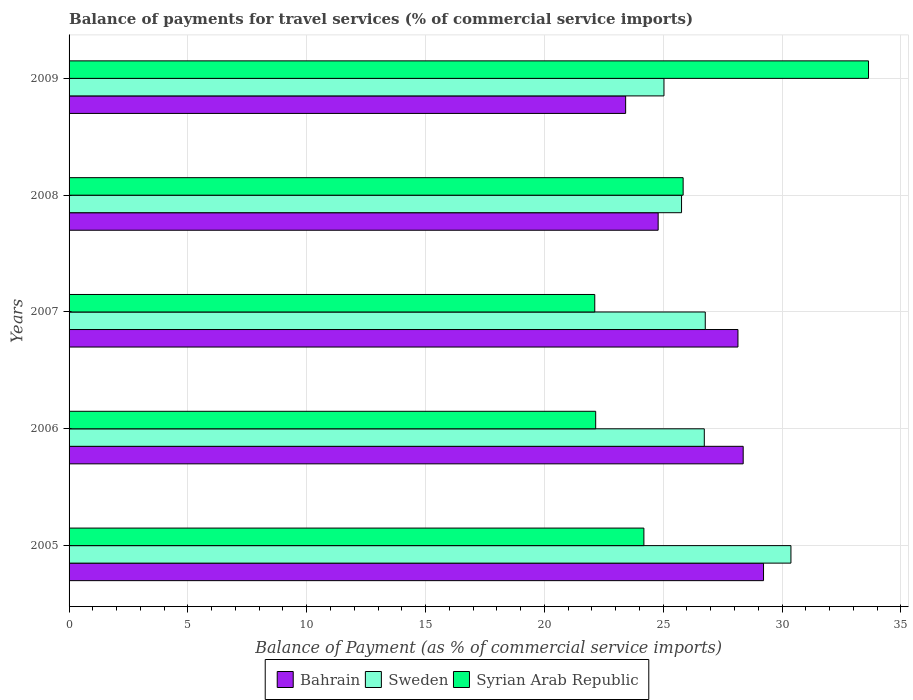How many groups of bars are there?
Ensure brevity in your answer.  5. Are the number of bars on each tick of the Y-axis equal?
Give a very brief answer. Yes. How many bars are there on the 4th tick from the bottom?
Your response must be concise. 3. What is the label of the 1st group of bars from the top?
Your response must be concise. 2009. In how many cases, is the number of bars for a given year not equal to the number of legend labels?
Your answer should be compact. 0. What is the balance of payments for travel services in Syrian Arab Republic in 2007?
Your response must be concise. 22.12. Across all years, what is the maximum balance of payments for travel services in Sweden?
Provide a succinct answer. 30.37. Across all years, what is the minimum balance of payments for travel services in Bahrain?
Keep it short and to the point. 23.42. In which year was the balance of payments for travel services in Bahrain maximum?
Offer a terse response. 2005. In which year was the balance of payments for travel services in Syrian Arab Republic minimum?
Your response must be concise. 2007. What is the total balance of payments for travel services in Bahrain in the graph?
Ensure brevity in your answer.  133.94. What is the difference between the balance of payments for travel services in Syrian Arab Republic in 2005 and that in 2006?
Your response must be concise. 2.03. What is the difference between the balance of payments for travel services in Syrian Arab Republic in 2006 and the balance of payments for travel services in Sweden in 2008?
Provide a succinct answer. -3.61. What is the average balance of payments for travel services in Syrian Arab Republic per year?
Your answer should be very brief. 25.59. In the year 2006, what is the difference between the balance of payments for travel services in Bahrain and balance of payments for travel services in Sweden?
Your response must be concise. 1.64. In how many years, is the balance of payments for travel services in Sweden greater than 15 %?
Keep it short and to the point. 5. What is the ratio of the balance of payments for travel services in Sweden in 2006 to that in 2009?
Your response must be concise. 1.07. Is the difference between the balance of payments for travel services in Bahrain in 2005 and 2008 greater than the difference between the balance of payments for travel services in Sweden in 2005 and 2008?
Your answer should be compact. No. What is the difference between the highest and the second highest balance of payments for travel services in Sweden?
Make the answer very short. 3.6. What is the difference between the highest and the lowest balance of payments for travel services in Sweden?
Provide a short and direct response. 5.34. In how many years, is the balance of payments for travel services in Syrian Arab Republic greater than the average balance of payments for travel services in Syrian Arab Republic taken over all years?
Offer a very short reply. 2. What does the 1st bar from the top in 2007 represents?
Your answer should be very brief. Syrian Arab Republic. What does the 3rd bar from the bottom in 2008 represents?
Give a very brief answer. Syrian Arab Republic. Is it the case that in every year, the sum of the balance of payments for travel services in Sweden and balance of payments for travel services in Bahrain is greater than the balance of payments for travel services in Syrian Arab Republic?
Offer a very short reply. Yes. How many bars are there?
Ensure brevity in your answer.  15. Are all the bars in the graph horizontal?
Give a very brief answer. Yes. What is the difference between two consecutive major ticks on the X-axis?
Your answer should be compact. 5. Are the values on the major ticks of X-axis written in scientific E-notation?
Your answer should be very brief. No. What is the title of the graph?
Offer a very short reply. Balance of payments for travel services (% of commercial service imports). Does "Chad" appear as one of the legend labels in the graph?
Offer a very short reply. No. What is the label or title of the X-axis?
Offer a terse response. Balance of Payment (as % of commercial service imports). What is the Balance of Payment (as % of commercial service imports) in Bahrain in 2005?
Your answer should be very brief. 29.22. What is the Balance of Payment (as % of commercial service imports) of Sweden in 2005?
Provide a short and direct response. 30.37. What is the Balance of Payment (as % of commercial service imports) in Syrian Arab Republic in 2005?
Your answer should be very brief. 24.19. What is the Balance of Payment (as % of commercial service imports) of Bahrain in 2006?
Provide a short and direct response. 28.36. What is the Balance of Payment (as % of commercial service imports) of Sweden in 2006?
Provide a succinct answer. 26.73. What is the Balance of Payment (as % of commercial service imports) of Syrian Arab Republic in 2006?
Keep it short and to the point. 22.16. What is the Balance of Payment (as % of commercial service imports) in Bahrain in 2007?
Ensure brevity in your answer.  28.14. What is the Balance of Payment (as % of commercial service imports) of Sweden in 2007?
Offer a terse response. 26.77. What is the Balance of Payment (as % of commercial service imports) of Syrian Arab Republic in 2007?
Offer a very short reply. 22.12. What is the Balance of Payment (as % of commercial service imports) of Bahrain in 2008?
Offer a terse response. 24.79. What is the Balance of Payment (as % of commercial service imports) of Sweden in 2008?
Offer a very short reply. 25.77. What is the Balance of Payment (as % of commercial service imports) of Syrian Arab Republic in 2008?
Your answer should be very brief. 25.84. What is the Balance of Payment (as % of commercial service imports) in Bahrain in 2009?
Your response must be concise. 23.42. What is the Balance of Payment (as % of commercial service imports) of Sweden in 2009?
Your response must be concise. 25.03. What is the Balance of Payment (as % of commercial service imports) of Syrian Arab Republic in 2009?
Provide a short and direct response. 33.64. Across all years, what is the maximum Balance of Payment (as % of commercial service imports) in Bahrain?
Give a very brief answer. 29.22. Across all years, what is the maximum Balance of Payment (as % of commercial service imports) in Sweden?
Your answer should be compact. 30.37. Across all years, what is the maximum Balance of Payment (as % of commercial service imports) of Syrian Arab Republic?
Make the answer very short. 33.64. Across all years, what is the minimum Balance of Payment (as % of commercial service imports) of Bahrain?
Give a very brief answer. 23.42. Across all years, what is the minimum Balance of Payment (as % of commercial service imports) in Sweden?
Give a very brief answer. 25.03. Across all years, what is the minimum Balance of Payment (as % of commercial service imports) of Syrian Arab Republic?
Make the answer very short. 22.12. What is the total Balance of Payment (as % of commercial service imports) of Bahrain in the graph?
Provide a succinct answer. 133.94. What is the total Balance of Payment (as % of commercial service imports) in Sweden in the graph?
Your answer should be very brief. 134.67. What is the total Balance of Payment (as % of commercial service imports) of Syrian Arab Republic in the graph?
Make the answer very short. 127.94. What is the difference between the Balance of Payment (as % of commercial service imports) in Bahrain in 2005 and that in 2006?
Your answer should be compact. 0.86. What is the difference between the Balance of Payment (as % of commercial service imports) in Sweden in 2005 and that in 2006?
Offer a very short reply. 3.65. What is the difference between the Balance of Payment (as % of commercial service imports) of Syrian Arab Republic in 2005 and that in 2006?
Provide a succinct answer. 2.03. What is the difference between the Balance of Payment (as % of commercial service imports) in Bahrain in 2005 and that in 2007?
Your response must be concise. 1.08. What is the difference between the Balance of Payment (as % of commercial service imports) in Sweden in 2005 and that in 2007?
Offer a very short reply. 3.6. What is the difference between the Balance of Payment (as % of commercial service imports) in Syrian Arab Republic in 2005 and that in 2007?
Provide a short and direct response. 2.07. What is the difference between the Balance of Payment (as % of commercial service imports) in Bahrain in 2005 and that in 2008?
Keep it short and to the point. 4.43. What is the difference between the Balance of Payment (as % of commercial service imports) of Sweden in 2005 and that in 2008?
Your answer should be very brief. 4.6. What is the difference between the Balance of Payment (as % of commercial service imports) of Syrian Arab Republic in 2005 and that in 2008?
Your answer should be very brief. -1.65. What is the difference between the Balance of Payment (as % of commercial service imports) of Bahrain in 2005 and that in 2009?
Make the answer very short. 5.8. What is the difference between the Balance of Payment (as % of commercial service imports) in Sweden in 2005 and that in 2009?
Your answer should be very brief. 5.34. What is the difference between the Balance of Payment (as % of commercial service imports) of Syrian Arab Republic in 2005 and that in 2009?
Provide a short and direct response. -9.45. What is the difference between the Balance of Payment (as % of commercial service imports) in Bahrain in 2006 and that in 2007?
Your answer should be compact. 0.22. What is the difference between the Balance of Payment (as % of commercial service imports) in Sweden in 2006 and that in 2007?
Provide a short and direct response. -0.04. What is the difference between the Balance of Payment (as % of commercial service imports) of Syrian Arab Republic in 2006 and that in 2007?
Keep it short and to the point. 0.04. What is the difference between the Balance of Payment (as % of commercial service imports) in Bahrain in 2006 and that in 2008?
Give a very brief answer. 3.58. What is the difference between the Balance of Payment (as % of commercial service imports) of Sweden in 2006 and that in 2008?
Provide a short and direct response. 0.96. What is the difference between the Balance of Payment (as % of commercial service imports) in Syrian Arab Republic in 2006 and that in 2008?
Keep it short and to the point. -3.68. What is the difference between the Balance of Payment (as % of commercial service imports) in Bahrain in 2006 and that in 2009?
Offer a terse response. 4.95. What is the difference between the Balance of Payment (as % of commercial service imports) of Sweden in 2006 and that in 2009?
Keep it short and to the point. 1.7. What is the difference between the Balance of Payment (as % of commercial service imports) in Syrian Arab Republic in 2006 and that in 2009?
Make the answer very short. -11.48. What is the difference between the Balance of Payment (as % of commercial service imports) in Bahrain in 2007 and that in 2008?
Keep it short and to the point. 3.36. What is the difference between the Balance of Payment (as % of commercial service imports) in Sweden in 2007 and that in 2008?
Offer a very short reply. 1. What is the difference between the Balance of Payment (as % of commercial service imports) in Syrian Arab Republic in 2007 and that in 2008?
Your response must be concise. -3.72. What is the difference between the Balance of Payment (as % of commercial service imports) in Bahrain in 2007 and that in 2009?
Your answer should be very brief. 4.73. What is the difference between the Balance of Payment (as % of commercial service imports) of Sweden in 2007 and that in 2009?
Your answer should be very brief. 1.74. What is the difference between the Balance of Payment (as % of commercial service imports) in Syrian Arab Republic in 2007 and that in 2009?
Ensure brevity in your answer.  -11.52. What is the difference between the Balance of Payment (as % of commercial service imports) in Bahrain in 2008 and that in 2009?
Ensure brevity in your answer.  1.37. What is the difference between the Balance of Payment (as % of commercial service imports) in Sweden in 2008 and that in 2009?
Keep it short and to the point. 0.74. What is the difference between the Balance of Payment (as % of commercial service imports) in Syrian Arab Republic in 2008 and that in 2009?
Give a very brief answer. -7.8. What is the difference between the Balance of Payment (as % of commercial service imports) in Bahrain in 2005 and the Balance of Payment (as % of commercial service imports) in Sweden in 2006?
Your answer should be compact. 2.49. What is the difference between the Balance of Payment (as % of commercial service imports) in Bahrain in 2005 and the Balance of Payment (as % of commercial service imports) in Syrian Arab Republic in 2006?
Provide a short and direct response. 7.06. What is the difference between the Balance of Payment (as % of commercial service imports) in Sweden in 2005 and the Balance of Payment (as % of commercial service imports) in Syrian Arab Republic in 2006?
Offer a very short reply. 8.22. What is the difference between the Balance of Payment (as % of commercial service imports) of Bahrain in 2005 and the Balance of Payment (as % of commercial service imports) of Sweden in 2007?
Your answer should be very brief. 2.45. What is the difference between the Balance of Payment (as % of commercial service imports) of Bahrain in 2005 and the Balance of Payment (as % of commercial service imports) of Syrian Arab Republic in 2007?
Keep it short and to the point. 7.1. What is the difference between the Balance of Payment (as % of commercial service imports) in Sweden in 2005 and the Balance of Payment (as % of commercial service imports) in Syrian Arab Republic in 2007?
Offer a very short reply. 8.25. What is the difference between the Balance of Payment (as % of commercial service imports) of Bahrain in 2005 and the Balance of Payment (as % of commercial service imports) of Sweden in 2008?
Offer a very short reply. 3.45. What is the difference between the Balance of Payment (as % of commercial service imports) of Bahrain in 2005 and the Balance of Payment (as % of commercial service imports) of Syrian Arab Republic in 2008?
Provide a succinct answer. 3.38. What is the difference between the Balance of Payment (as % of commercial service imports) of Sweden in 2005 and the Balance of Payment (as % of commercial service imports) of Syrian Arab Republic in 2008?
Provide a succinct answer. 4.54. What is the difference between the Balance of Payment (as % of commercial service imports) in Bahrain in 2005 and the Balance of Payment (as % of commercial service imports) in Sweden in 2009?
Provide a succinct answer. 4.19. What is the difference between the Balance of Payment (as % of commercial service imports) of Bahrain in 2005 and the Balance of Payment (as % of commercial service imports) of Syrian Arab Republic in 2009?
Your response must be concise. -4.42. What is the difference between the Balance of Payment (as % of commercial service imports) in Sweden in 2005 and the Balance of Payment (as % of commercial service imports) in Syrian Arab Republic in 2009?
Keep it short and to the point. -3.26. What is the difference between the Balance of Payment (as % of commercial service imports) of Bahrain in 2006 and the Balance of Payment (as % of commercial service imports) of Sweden in 2007?
Offer a very short reply. 1.6. What is the difference between the Balance of Payment (as % of commercial service imports) of Bahrain in 2006 and the Balance of Payment (as % of commercial service imports) of Syrian Arab Republic in 2007?
Provide a succinct answer. 6.24. What is the difference between the Balance of Payment (as % of commercial service imports) in Sweden in 2006 and the Balance of Payment (as % of commercial service imports) in Syrian Arab Republic in 2007?
Keep it short and to the point. 4.61. What is the difference between the Balance of Payment (as % of commercial service imports) of Bahrain in 2006 and the Balance of Payment (as % of commercial service imports) of Sweden in 2008?
Provide a short and direct response. 2.59. What is the difference between the Balance of Payment (as % of commercial service imports) of Bahrain in 2006 and the Balance of Payment (as % of commercial service imports) of Syrian Arab Republic in 2008?
Make the answer very short. 2.53. What is the difference between the Balance of Payment (as % of commercial service imports) in Sweden in 2006 and the Balance of Payment (as % of commercial service imports) in Syrian Arab Republic in 2008?
Your response must be concise. 0.89. What is the difference between the Balance of Payment (as % of commercial service imports) of Bahrain in 2006 and the Balance of Payment (as % of commercial service imports) of Syrian Arab Republic in 2009?
Your response must be concise. -5.27. What is the difference between the Balance of Payment (as % of commercial service imports) of Sweden in 2006 and the Balance of Payment (as % of commercial service imports) of Syrian Arab Republic in 2009?
Offer a very short reply. -6.91. What is the difference between the Balance of Payment (as % of commercial service imports) of Bahrain in 2007 and the Balance of Payment (as % of commercial service imports) of Sweden in 2008?
Your answer should be very brief. 2.37. What is the difference between the Balance of Payment (as % of commercial service imports) of Bahrain in 2007 and the Balance of Payment (as % of commercial service imports) of Syrian Arab Republic in 2008?
Give a very brief answer. 2.31. What is the difference between the Balance of Payment (as % of commercial service imports) in Sweden in 2007 and the Balance of Payment (as % of commercial service imports) in Syrian Arab Republic in 2008?
Offer a very short reply. 0.93. What is the difference between the Balance of Payment (as % of commercial service imports) of Bahrain in 2007 and the Balance of Payment (as % of commercial service imports) of Sweden in 2009?
Keep it short and to the point. 3.11. What is the difference between the Balance of Payment (as % of commercial service imports) in Bahrain in 2007 and the Balance of Payment (as % of commercial service imports) in Syrian Arab Republic in 2009?
Give a very brief answer. -5.49. What is the difference between the Balance of Payment (as % of commercial service imports) in Sweden in 2007 and the Balance of Payment (as % of commercial service imports) in Syrian Arab Republic in 2009?
Offer a very short reply. -6.87. What is the difference between the Balance of Payment (as % of commercial service imports) in Bahrain in 2008 and the Balance of Payment (as % of commercial service imports) in Sweden in 2009?
Your answer should be compact. -0.24. What is the difference between the Balance of Payment (as % of commercial service imports) of Bahrain in 2008 and the Balance of Payment (as % of commercial service imports) of Syrian Arab Republic in 2009?
Offer a very short reply. -8.85. What is the difference between the Balance of Payment (as % of commercial service imports) in Sweden in 2008 and the Balance of Payment (as % of commercial service imports) in Syrian Arab Republic in 2009?
Offer a terse response. -7.87. What is the average Balance of Payment (as % of commercial service imports) in Bahrain per year?
Your answer should be compact. 26.79. What is the average Balance of Payment (as % of commercial service imports) in Sweden per year?
Give a very brief answer. 26.93. What is the average Balance of Payment (as % of commercial service imports) in Syrian Arab Republic per year?
Offer a terse response. 25.59. In the year 2005, what is the difference between the Balance of Payment (as % of commercial service imports) in Bahrain and Balance of Payment (as % of commercial service imports) in Sweden?
Provide a succinct answer. -1.15. In the year 2005, what is the difference between the Balance of Payment (as % of commercial service imports) in Bahrain and Balance of Payment (as % of commercial service imports) in Syrian Arab Republic?
Offer a very short reply. 5.03. In the year 2005, what is the difference between the Balance of Payment (as % of commercial service imports) in Sweden and Balance of Payment (as % of commercial service imports) in Syrian Arab Republic?
Give a very brief answer. 6.19. In the year 2006, what is the difference between the Balance of Payment (as % of commercial service imports) of Bahrain and Balance of Payment (as % of commercial service imports) of Sweden?
Offer a very short reply. 1.64. In the year 2006, what is the difference between the Balance of Payment (as % of commercial service imports) of Bahrain and Balance of Payment (as % of commercial service imports) of Syrian Arab Republic?
Offer a terse response. 6.21. In the year 2006, what is the difference between the Balance of Payment (as % of commercial service imports) in Sweden and Balance of Payment (as % of commercial service imports) in Syrian Arab Republic?
Your answer should be very brief. 4.57. In the year 2007, what is the difference between the Balance of Payment (as % of commercial service imports) of Bahrain and Balance of Payment (as % of commercial service imports) of Sweden?
Keep it short and to the point. 1.38. In the year 2007, what is the difference between the Balance of Payment (as % of commercial service imports) in Bahrain and Balance of Payment (as % of commercial service imports) in Syrian Arab Republic?
Your answer should be compact. 6.03. In the year 2007, what is the difference between the Balance of Payment (as % of commercial service imports) of Sweden and Balance of Payment (as % of commercial service imports) of Syrian Arab Republic?
Provide a short and direct response. 4.65. In the year 2008, what is the difference between the Balance of Payment (as % of commercial service imports) in Bahrain and Balance of Payment (as % of commercial service imports) in Sweden?
Ensure brevity in your answer.  -0.98. In the year 2008, what is the difference between the Balance of Payment (as % of commercial service imports) of Bahrain and Balance of Payment (as % of commercial service imports) of Syrian Arab Republic?
Give a very brief answer. -1.05. In the year 2008, what is the difference between the Balance of Payment (as % of commercial service imports) of Sweden and Balance of Payment (as % of commercial service imports) of Syrian Arab Republic?
Make the answer very short. -0.07. In the year 2009, what is the difference between the Balance of Payment (as % of commercial service imports) in Bahrain and Balance of Payment (as % of commercial service imports) in Sweden?
Keep it short and to the point. -1.61. In the year 2009, what is the difference between the Balance of Payment (as % of commercial service imports) in Bahrain and Balance of Payment (as % of commercial service imports) in Syrian Arab Republic?
Your answer should be compact. -10.22. In the year 2009, what is the difference between the Balance of Payment (as % of commercial service imports) of Sweden and Balance of Payment (as % of commercial service imports) of Syrian Arab Republic?
Make the answer very short. -8.61. What is the ratio of the Balance of Payment (as % of commercial service imports) of Bahrain in 2005 to that in 2006?
Ensure brevity in your answer.  1.03. What is the ratio of the Balance of Payment (as % of commercial service imports) in Sweden in 2005 to that in 2006?
Keep it short and to the point. 1.14. What is the ratio of the Balance of Payment (as % of commercial service imports) of Syrian Arab Republic in 2005 to that in 2006?
Offer a very short reply. 1.09. What is the ratio of the Balance of Payment (as % of commercial service imports) of Bahrain in 2005 to that in 2007?
Offer a terse response. 1.04. What is the ratio of the Balance of Payment (as % of commercial service imports) of Sweden in 2005 to that in 2007?
Your answer should be compact. 1.13. What is the ratio of the Balance of Payment (as % of commercial service imports) of Syrian Arab Republic in 2005 to that in 2007?
Your answer should be very brief. 1.09. What is the ratio of the Balance of Payment (as % of commercial service imports) of Bahrain in 2005 to that in 2008?
Keep it short and to the point. 1.18. What is the ratio of the Balance of Payment (as % of commercial service imports) of Sweden in 2005 to that in 2008?
Provide a succinct answer. 1.18. What is the ratio of the Balance of Payment (as % of commercial service imports) in Syrian Arab Republic in 2005 to that in 2008?
Your response must be concise. 0.94. What is the ratio of the Balance of Payment (as % of commercial service imports) in Bahrain in 2005 to that in 2009?
Keep it short and to the point. 1.25. What is the ratio of the Balance of Payment (as % of commercial service imports) in Sweden in 2005 to that in 2009?
Your answer should be compact. 1.21. What is the ratio of the Balance of Payment (as % of commercial service imports) of Syrian Arab Republic in 2005 to that in 2009?
Offer a very short reply. 0.72. What is the ratio of the Balance of Payment (as % of commercial service imports) in Bahrain in 2006 to that in 2008?
Provide a succinct answer. 1.14. What is the ratio of the Balance of Payment (as % of commercial service imports) of Sweden in 2006 to that in 2008?
Your answer should be compact. 1.04. What is the ratio of the Balance of Payment (as % of commercial service imports) of Syrian Arab Republic in 2006 to that in 2008?
Offer a very short reply. 0.86. What is the ratio of the Balance of Payment (as % of commercial service imports) in Bahrain in 2006 to that in 2009?
Your answer should be very brief. 1.21. What is the ratio of the Balance of Payment (as % of commercial service imports) in Sweden in 2006 to that in 2009?
Keep it short and to the point. 1.07. What is the ratio of the Balance of Payment (as % of commercial service imports) of Syrian Arab Republic in 2006 to that in 2009?
Offer a terse response. 0.66. What is the ratio of the Balance of Payment (as % of commercial service imports) in Bahrain in 2007 to that in 2008?
Provide a succinct answer. 1.14. What is the ratio of the Balance of Payment (as % of commercial service imports) in Sweden in 2007 to that in 2008?
Offer a very short reply. 1.04. What is the ratio of the Balance of Payment (as % of commercial service imports) of Syrian Arab Republic in 2007 to that in 2008?
Give a very brief answer. 0.86. What is the ratio of the Balance of Payment (as % of commercial service imports) of Bahrain in 2007 to that in 2009?
Your response must be concise. 1.2. What is the ratio of the Balance of Payment (as % of commercial service imports) of Sweden in 2007 to that in 2009?
Your response must be concise. 1.07. What is the ratio of the Balance of Payment (as % of commercial service imports) of Syrian Arab Republic in 2007 to that in 2009?
Your answer should be compact. 0.66. What is the ratio of the Balance of Payment (as % of commercial service imports) in Bahrain in 2008 to that in 2009?
Provide a short and direct response. 1.06. What is the ratio of the Balance of Payment (as % of commercial service imports) in Sweden in 2008 to that in 2009?
Ensure brevity in your answer.  1.03. What is the ratio of the Balance of Payment (as % of commercial service imports) in Syrian Arab Republic in 2008 to that in 2009?
Offer a very short reply. 0.77. What is the difference between the highest and the second highest Balance of Payment (as % of commercial service imports) of Bahrain?
Ensure brevity in your answer.  0.86. What is the difference between the highest and the second highest Balance of Payment (as % of commercial service imports) of Sweden?
Your answer should be compact. 3.6. What is the difference between the highest and the second highest Balance of Payment (as % of commercial service imports) in Syrian Arab Republic?
Your answer should be compact. 7.8. What is the difference between the highest and the lowest Balance of Payment (as % of commercial service imports) of Bahrain?
Keep it short and to the point. 5.8. What is the difference between the highest and the lowest Balance of Payment (as % of commercial service imports) of Sweden?
Keep it short and to the point. 5.34. What is the difference between the highest and the lowest Balance of Payment (as % of commercial service imports) in Syrian Arab Republic?
Offer a terse response. 11.52. 